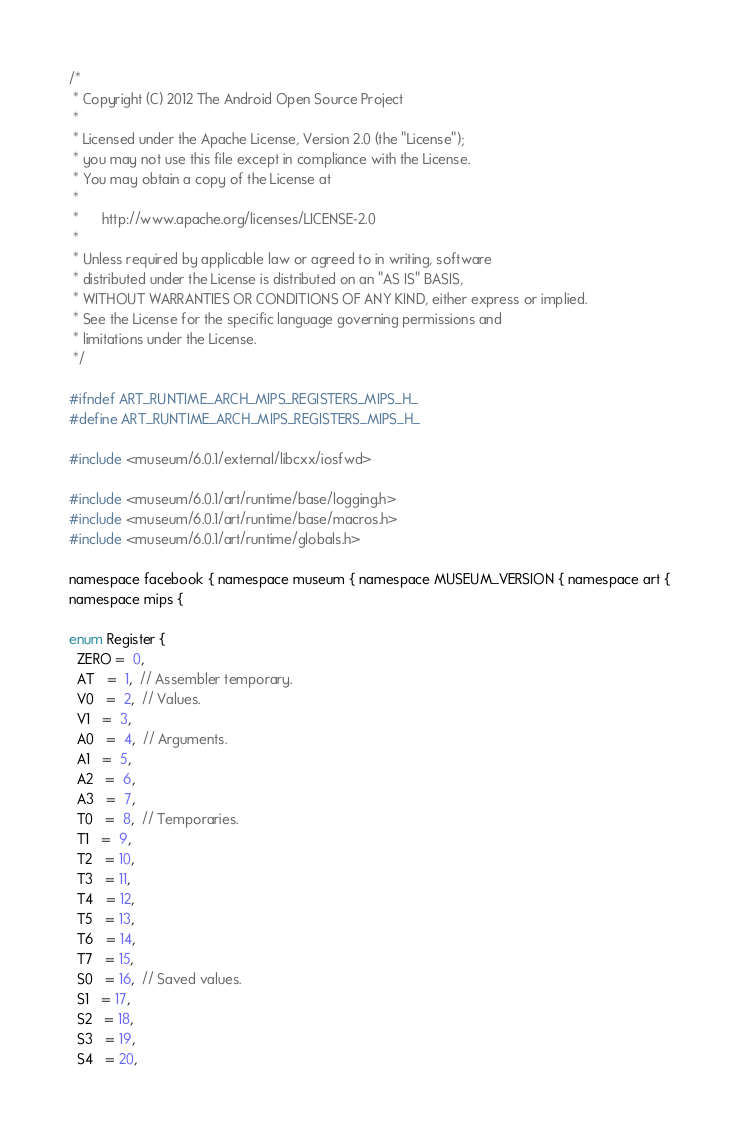<code> <loc_0><loc_0><loc_500><loc_500><_C_>/*
 * Copyright (C) 2012 The Android Open Source Project
 *
 * Licensed under the Apache License, Version 2.0 (the "License");
 * you may not use this file except in compliance with the License.
 * You may obtain a copy of the License at
 *
 *      http://www.apache.org/licenses/LICENSE-2.0
 *
 * Unless required by applicable law or agreed to in writing, software
 * distributed under the License is distributed on an "AS IS" BASIS,
 * WITHOUT WARRANTIES OR CONDITIONS OF ANY KIND, either express or implied.
 * See the License for the specific language governing permissions and
 * limitations under the License.
 */

#ifndef ART_RUNTIME_ARCH_MIPS_REGISTERS_MIPS_H_
#define ART_RUNTIME_ARCH_MIPS_REGISTERS_MIPS_H_

#include <museum/6.0.1/external/libcxx/iosfwd>

#include <museum/6.0.1/art/runtime/base/logging.h>
#include <museum/6.0.1/art/runtime/base/macros.h>
#include <museum/6.0.1/art/runtime/globals.h>

namespace facebook { namespace museum { namespace MUSEUM_VERSION { namespace art {
namespace mips {

enum Register {
  ZERO =  0,
  AT   =  1,  // Assembler temporary.
  V0   =  2,  // Values.
  V1   =  3,
  A0   =  4,  // Arguments.
  A1   =  5,
  A2   =  6,
  A3   =  7,
  T0   =  8,  // Temporaries.
  T1   =  9,
  T2   = 10,
  T3   = 11,
  T4   = 12,
  T5   = 13,
  T6   = 14,
  T7   = 15,
  S0   = 16,  // Saved values.
  S1   = 17,
  S2   = 18,
  S3   = 19,
  S4   = 20,</code> 